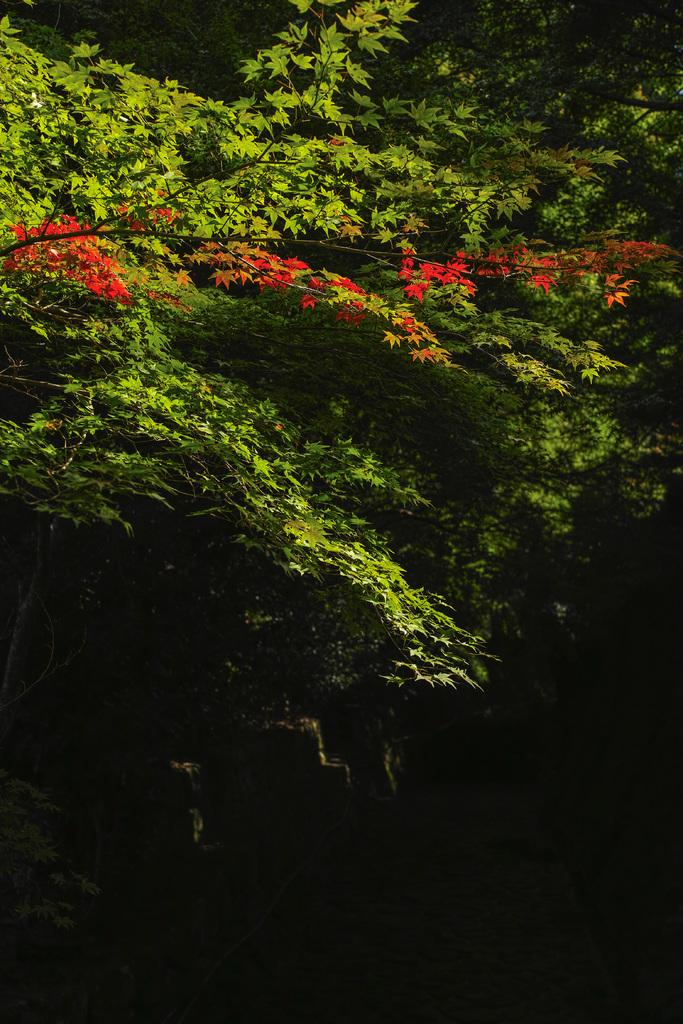What type of vegetation can be seen in the image? There are trees in the image. What color are the leaves on the trees? There are green leaves and red leaves on the trees. What color is the background of the image? The background of the image is black. What type of stocking is hanging from the tree in the image? There is no stocking hanging from the tree in the image; it only features trees with green and red leaves against a black background. 